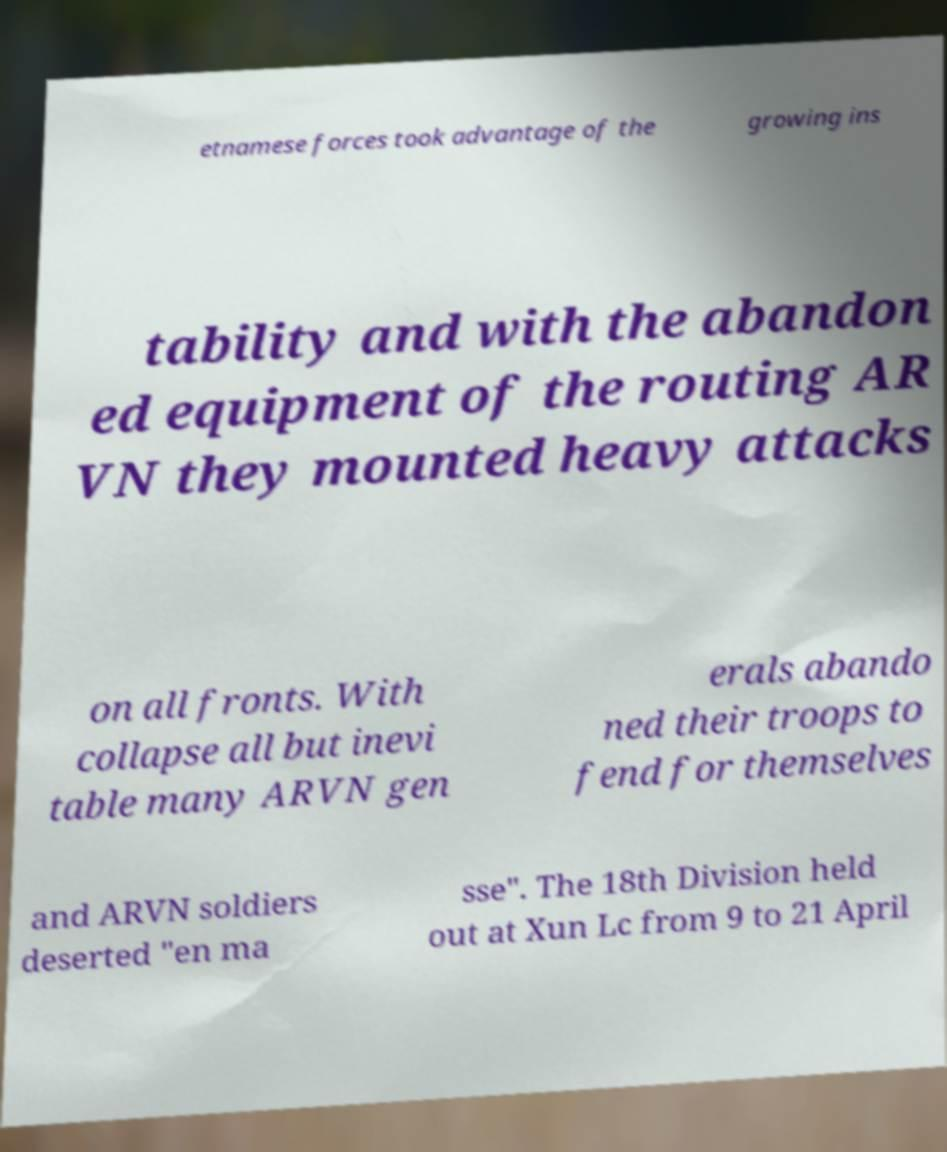Could you extract and type out the text from this image? etnamese forces took advantage of the growing ins tability and with the abandon ed equipment of the routing AR VN they mounted heavy attacks on all fronts. With collapse all but inevi table many ARVN gen erals abando ned their troops to fend for themselves and ARVN soldiers deserted "en ma sse". The 18th Division held out at Xun Lc from 9 to 21 April 